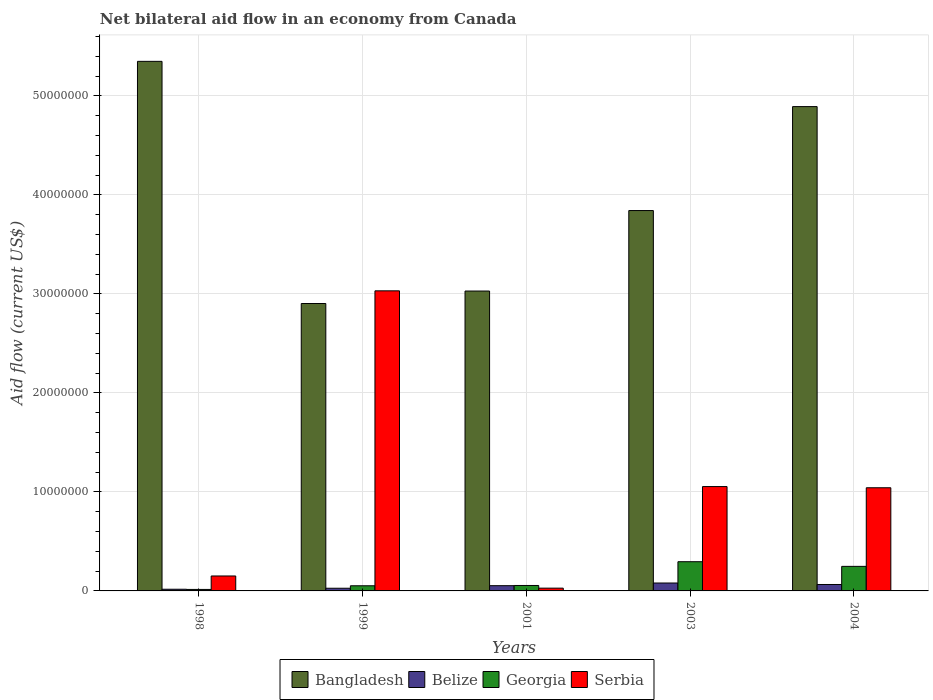How many groups of bars are there?
Ensure brevity in your answer.  5. Are the number of bars per tick equal to the number of legend labels?
Provide a succinct answer. Yes. Are the number of bars on each tick of the X-axis equal?
Offer a terse response. Yes. How many bars are there on the 3rd tick from the left?
Your response must be concise. 4. In how many cases, is the number of bars for a given year not equal to the number of legend labels?
Make the answer very short. 0. Across all years, what is the maximum net bilateral aid flow in Georgia?
Provide a succinct answer. 2.95e+06. Across all years, what is the minimum net bilateral aid flow in Georgia?
Your answer should be compact. 1.50e+05. What is the total net bilateral aid flow in Bangladesh in the graph?
Offer a very short reply. 2.00e+08. What is the difference between the net bilateral aid flow in Serbia in 2003 and that in 2004?
Offer a very short reply. 1.20e+05. What is the difference between the net bilateral aid flow in Bangladesh in 2003 and the net bilateral aid flow in Belize in 2004?
Ensure brevity in your answer.  3.78e+07. What is the average net bilateral aid flow in Bangladesh per year?
Your answer should be very brief. 4.00e+07. In the year 2001, what is the difference between the net bilateral aid flow in Georgia and net bilateral aid flow in Bangladesh?
Ensure brevity in your answer.  -2.97e+07. In how many years, is the net bilateral aid flow in Georgia greater than 40000000 US$?
Provide a short and direct response. 0. What is the ratio of the net bilateral aid flow in Georgia in 1998 to that in 2003?
Give a very brief answer. 0.05. What is the difference between the highest and the second highest net bilateral aid flow in Serbia?
Your answer should be very brief. 1.98e+07. What is the difference between the highest and the lowest net bilateral aid flow in Bangladesh?
Provide a succinct answer. 2.45e+07. Is the sum of the net bilateral aid flow in Georgia in 2001 and 2003 greater than the maximum net bilateral aid flow in Serbia across all years?
Keep it short and to the point. No. Is it the case that in every year, the sum of the net bilateral aid flow in Georgia and net bilateral aid flow in Belize is greater than the sum of net bilateral aid flow in Serbia and net bilateral aid flow in Bangladesh?
Make the answer very short. No. What does the 4th bar from the left in 1999 represents?
Your response must be concise. Serbia. What does the 2nd bar from the right in 1999 represents?
Your answer should be compact. Georgia. Is it the case that in every year, the sum of the net bilateral aid flow in Georgia and net bilateral aid flow in Bangladesh is greater than the net bilateral aid flow in Belize?
Offer a very short reply. Yes. Are all the bars in the graph horizontal?
Your answer should be very brief. No. How many years are there in the graph?
Provide a short and direct response. 5. What is the difference between two consecutive major ticks on the Y-axis?
Offer a terse response. 1.00e+07. Are the values on the major ticks of Y-axis written in scientific E-notation?
Provide a short and direct response. No. Does the graph contain grids?
Make the answer very short. Yes. Where does the legend appear in the graph?
Ensure brevity in your answer.  Bottom center. What is the title of the graph?
Provide a succinct answer. Net bilateral aid flow in an economy from Canada. Does "Equatorial Guinea" appear as one of the legend labels in the graph?
Offer a terse response. No. What is the label or title of the X-axis?
Make the answer very short. Years. What is the Aid flow (current US$) in Bangladesh in 1998?
Make the answer very short. 5.35e+07. What is the Aid flow (current US$) of Georgia in 1998?
Provide a succinct answer. 1.50e+05. What is the Aid flow (current US$) of Serbia in 1998?
Offer a very short reply. 1.51e+06. What is the Aid flow (current US$) in Bangladesh in 1999?
Your response must be concise. 2.90e+07. What is the Aid flow (current US$) in Belize in 1999?
Keep it short and to the point. 2.70e+05. What is the Aid flow (current US$) of Georgia in 1999?
Ensure brevity in your answer.  5.20e+05. What is the Aid flow (current US$) in Serbia in 1999?
Ensure brevity in your answer.  3.03e+07. What is the Aid flow (current US$) in Bangladesh in 2001?
Your answer should be compact. 3.03e+07. What is the Aid flow (current US$) in Belize in 2001?
Your answer should be very brief. 5.30e+05. What is the Aid flow (current US$) of Bangladesh in 2003?
Provide a succinct answer. 3.84e+07. What is the Aid flow (current US$) of Georgia in 2003?
Provide a short and direct response. 2.95e+06. What is the Aid flow (current US$) in Serbia in 2003?
Keep it short and to the point. 1.05e+07. What is the Aid flow (current US$) in Bangladesh in 2004?
Ensure brevity in your answer.  4.89e+07. What is the Aid flow (current US$) of Belize in 2004?
Your response must be concise. 6.50e+05. What is the Aid flow (current US$) of Georgia in 2004?
Your answer should be very brief. 2.48e+06. What is the Aid flow (current US$) in Serbia in 2004?
Offer a very short reply. 1.04e+07. Across all years, what is the maximum Aid flow (current US$) of Bangladesh?
Provide a short and direct response. 5.35e+07. Across all years, what is the maximum Aid flow (current US$) of Georgia?
Offer a very short reply. 2.95e+06. Across all years, what is the maximum Aid flow (current US$) in Serbia?
Keep it short and to the point. 3.03e+07. Across all years, what is the minimum Aid flow (current US$) of Bangladesh?
Make the answer very short. 2.90e+07. Across all years, what is the minimum Aid flow (current US$) in Georgia?
Keep it short and to the point. 1.50e+05. Across all years, what is the minimum Aid flow (current US$) of Serbia?
Your answer should be very brief. 2.80e+05. What is the total Aid flow (current US$) of Bangladesh in the graph?
Give a very brief answer. 2.00e+08. What is the total Aid flow (current US$) in Belize in the graph?
Keep it short and to the point. 2.42e+06. What is the total Aid flow (current US$) of Georgia in the graph?
Make the answer very short. 6.65e+06. What is the total Aid flow (current US$) of Serbia in the graph?
Ensure brevity in your answer.  5.31e+07. What is the difference between the Aid flow (current US$) in Bangladesh in 1998 and that in 1999?
Provide a succinct answer. 2.45e+07. What is the difference between the Aid flow (current US$) of Georgia in 1998 and that in 1999?
Give a very brief answer. -3.70e+05. What is the difference between the Aid flow (current US$) in Serbia in 1998 and that in 1999?
Offer a terse response. -2.88e+07. What is the difference between the Aid flow (current US$) in Bangladesh in 1998 and that in 2001?
Provide a short and direct response. 2.32e+07. What is the difference between the Aid flow (current US$) in Belize in 1998 and that in 2001?
Your answer should be very brief. -3.60e+05. What is the difference between the Aid flow (current US$) in Georgia in 1998 and that in 2001?
Give a very brief answer. -4.00e+05. What is the difference between the Aid flow (current US$) of Serbia in 1998 and that in 2001?
Keep it short and to the point. 1.23e+06. What is the difference between the Aid flow (current US$) of Bangladesh in 1998 and that in 2003?
Offer a terse response. 1.51e+07. What is the difference between the Aid flow (current US$) of Belize in 1998 and that in 2003?
Ensure brevity in your answer.  -6.30e+05. What is the difference between the Aid flow (current US$) of Georgia in 1998 and that in 2003?
Keep it short and to the point. -2.80e+06. What is the difference between the Aid flow (current US$) in Serbia in 1998 and that in 2003?
Your answer should be very brief. -9.03e+06. What is the difference between the Aid flow (current US$) in Bangladesh in 1998 and that in 2004?
Make the answer very short. 4.57e+06. What is the difference between the Aid flow (current US$) in Belize in 1998 and that in 2004?
Make the answer very short. -4.80e+05. What is the difference between the Aid flow (current US$) in Georgia in 1998 and that in 2004?
Offer a very short reply. -2.33e+06. What is the difference between the Aid flow (current US$) of Serbia in 1998 and that in 2004?
Make the answer very short. -8.91e+06. What is the difference between the Aid flow (current US$) of Bangladesh in 1999 and that in 2001?
Provide a succinct answer. -1.26e+06. What is the difference between the Aid flow (current US$) of Serbia in 1999 and that in 2001?
Offer a very short reply. 3.00e+07. What is the difference between the Aid flow (current US$) in Bangladesh in 1999 and that in 2003?
Ensure brevity in your answer.  -9.39e+06. What is the difference between the Aid flow (current US$) of Belize in 1999 and that in 2003?
Your answer should be very brief. -5.30e+05. What is the difference between the Aid flow (current US$) of Georgia in 1999 and that in 2003?
Give a very brief answer. -2.43e+06. What is the difference between the Aid flow (current US$) of Serbia in 1999 and that in 2003?
Give a very brief answer. 1.98e+07. What is the difference between the Aid flow (current US$) in Bangladesh in 1999 and that in 2004?
Your answer should be compact. -1.99e+07. What is the difference between the Aid flow (current US$) of Belize in 1999 and that in 2004?
Provide a short and direct response. -3.80e+05. What is the difference between the Aid flow (current US$) in Georgia in 1999 and that in 2004?
Offer a terse response. -1.96e+06. What is the difference between the Aid flow (current US$) in Serbia in 1999 and that in 2004?
Make the answer very short. 1.99e+07. What is the difference between the Aid flow (current US$) in Bangladesh in 2001 and that in 2003?
Provide a succinct answer. -8.13e+06. What is the difference between the Aid flow (current US$) in Belize in 2001 and that in 2003?
Give a very brief answer. -2.70e+05. What is the difference between the Aid flow (current US$) of Georgia in 2001 and that in 2003?
Give a very brief answer. -2.40e+06. What is the difference between the Aid flow (current US$) in Serbia in 2001 and that in 2003?
Your answer should be compact. -1.03e+07. What is the difference between the Aid flow (current US$) in Bangladesh in 2001 and that in 2004?
Make the answer very short. -1.86e+07. What is the difference between the Aid flow (current US$) in Georgia in 2001 and that in 2004?
Make the answer very short. -1.93e+06. What is the difference between the Aid flow (current US$) of Serbia in 2001 and that in 2004?
Your answer should be compact. -1.01e+07. What is the difference between the Aid flow (current US$) of Bangladesh in 2003 and that in 2004?
Provide a succinct answer. -1.05e+07. What is the difference between the Aid flow (current US$) of Serbia in 2003 and that in 2004?
Provide a short and direct response. 1.20e+05. What is the difference between the Aid flow (current US$) in Bangladesh in 1998 and the Aid flow (current US$) in Belize in 1999?
Offer a terse response. 5.32e+07. What is the difference between the Aid flow (current US$) in Bangladesh in 1998 and the Aid flow (current US$) in Georgia in 1999?
Ensure brevity in your answer.  5.30e+07. What is the difference between the Aid flow (current US$) of Bangladesh in 1998 and the Aid flow (current US$) of Serbia in 1999?
Give a very brief answer. 2.32e+07. What is the difference between the Aid flow (current US$) in Belize in 1998 and the Aid flow (current US$) in Georgia in 1999?
Your answer should be very brief. -3.50e+05. What is the difference between the Aid flow (current US$) in Belize in 1998 and the Aid flow (current US$) in Serbia in 1999?
Give a very brief answer. -3.01e+07. What is the difference between the Aid flow (current US$) of Georgia in 1998 and the Aid flow (current US$) of Serbia in 1999?
Provide a succinct answer. -3.02e+07. What is the difference between the Aid flow (current US$) of Bangladesh in 1998 and the Aid flow (current US$) of Belize in 2001?
Ensure brevity in your answer.  5.30e+07. What is the difference between the Aid flow (current US$) of Bangladesh in 1998 and the Aid flow (current US$) of Georgia in 2001?
Your response must be concise. 5.29e+07. What is the difference between the Aid flow (current US$) of Bangladesh in 1998 and the Aid flow (current US$) of Serbia in 2001?
Make the answer very short. 5.32e+07. What is the difference between the Aid flow (current US$) of Belize in 1998 and the Aid flow (current US$) of Georgia in 2001?
Your response must be concise. -3.80e+05. What is the difference between the Aid flow (current US$) of Belize in 1998 and the Aid flow (current US$) of Serbia in 2001?
Offer a very short reply. -1.10e+05. What is the difference between the Aid flow (current US$) in Georgia in 1998 and the Aid flow (current US$) in Serbia in 2001?
Your answer should be very brief. -1.30e+05. What is the difference between the Aid flow (current US$) in Bangladesh in 1998 and the Aid flow (current US$) in Belize in 2003?
Offer a terse response. 5.27e+07. What is the difference between the Aid flow (current US$) in Bangladesh in 1998 and the Aid flow (current US$) in Georgia in 2003?
Make the answer very short. 5.05e+07. What is the difference between the Aid flow (current US$) in Bangladesh in 1998 and the Aid flow (current US$) in Serbia in 2003?
Offer a terse response. 4.30e+07. What is the difference between the Aid flow (current US$) of Belize in 1998 and the Aid flow (current US$) of Georgia in 2003?
Offer a terse response. -2.78e+06. What is the difference between the Aid flow (current US$) in Belize in 1998 and the Aid flow (current US$) in Serbia in 2003?
Offer a very short reply. -1.04e+07. What is the difference between the Aid flow (current US$) in Georgia in 1998 and the Aid flow (current US$) in Serbia in 2003?
Keep it short and to the point. -1.04e+07. What is the difference between the Aid flow (current US$) in Bangladesh in 1998 and the Aid flow (current US$) in Belize in 2004?
Keep it short and to the point. 5.28e+07. What is the difference between the Aid flow (current US$) in Bangladesh in 1998 and the Aid flow (current US$) in Georgia in 2004?
Provide a succinct answer. 5.10e+07. What is the difference between the Aid flow (current US$) of Bangladesh in 1998 and the Aid flow (current US$) of Serbia in 2004?
Keep it short and to the point. 4.31e+07. What is the difference between the Aid flow (current US$) of Belize in 1998 and the Aid flow (current US$) of Georgia in 2004?
Give a very brief answer. -2.31e+06. What is the difference between the Aid flow (current US$) in Belize in 1998 and the Aid flow (current US$) in Serbia in 2004?
Your answer should be very brief. -1.02e+07. What is the difference between the Aid flow (current US$) of Georgia in 1998 and the Aid flow (current US$) of Serbia in 2004?
Provide a succinct answer. -1.03e+07. What is the difference between the Aid flow (current US$) of Bangladesh in 1999 and the Aid flow (current US$) of Belize in 2001?
Give a very brief answer. 2.85e+07. What is the difference between the Aid flow (current US$) of Bangladesh in 1999 and the Aid flow (current US$) of Georgia in 2001?
Offer a terse response. 2.85e+07. What is the difference between the Aid flow (current US$) in Bangladesh in 1999 and the Aid flow (current US$) in Serbia in 2001?
Offer a terse response. 2.88e+07. What is the difference between the Aid flow (current US$) of Belize in 1999 and the Aid flow (current US$) of Georgia in 2001?
Provide a short and direct response. -2.80e+05. What is the difference between the Aid flow (current US$) of Belize in 1999 and the Aid flow (current US$) of Serbia in 2001?
Your answer should be compact. -10000. What is the difference between the Aid flow (current US$) of Georgia in 1999 and the Aid flow (current US$) of Serbia in 2001?
Your response must be concise. 2.40e+05. What is the difference between the Aid flow (current US$) of Bangladesh in 1999 and the Aid flow (current US$) of Belize in 2003?
Make the answer very short. 2.82e+07. What is the difference between the Aid flow (current US$) in Bangladesh in 1999 and the Aid flow (current US$) in Georgia in 2003?
Keep it short and to the point. 2.61e+07. What is the difference between the Aid flow (current US$) in Bangladesh in 1999 and the Aid flow (current US$) in Serbia in 2003?
Provide a succinct answer. 1.85e+07. What is the difference between the Aid flow (current US$) of Belize in 1999 and the Aid flow (current US$) of Georgia in 2003?
Provide a succinct answer. -2.68e+06. What is the difference between the Aid flow (current US$) of Belize in 1999 and the Aid flow (current US$) of Serbia in 2003?
Keep it short and to the point. -1.03e+07. What is the difference between the Aid flow (current US$) in Georgia in 1999 and the Aid flow (current US$) in Serbia in 2003?
Provide a succinct answer. -1.00e+07. What is the difference between the Aid flow (current US$) of Bangladesh in 1999 and the Aid flow (current US$) of Belize in 2004?
Make the answer very short. 2.84e+07. What is the difference between the Aid flow (current US$) in Bangladesh in 1999 and the Aid flow (current US$) in Georgia in 2004?
Provide a succinct answer. 2.66e+07. What is the difference between the Aid flow (current US$) in Bangladesh in 1999 and the Aid flow (current US$) in Serbia in 2004?
Keep it short and to the point. 1.86e+07. What is the difference between the Aid flow (current US$) of Belize in 1999 and the Aid flow (current US$) of Georgia in 2004?
Keep it short and to the point. -2.21e+06. What is the difference between the Aid flow (current US$) of Belize in 1999 and the Aid flow (current US$) of Serbia in 2004?
Provide a short and direct response. -1.02e+07. What is the difference between the Aid flow (current US$) of Georgia in 1999 and the Aid flow (current US$) of Serbia in 2004?
Make the answer very short. -9.90e+06. What is the difference between the Aid flow (current US$) in Bangladesh in 2001 and the Aid flow (current US$) in Belize in 2003?
Provide a short and direct response. 2.95e+07. What is the difference between the Aid flow (current US$) of Bangladesh in 2001 and the Aid flow (current US$) of Georgia in 2003?
Your response must be concise. 2.73e+07. What is the difference between the Aid flow (current US$) in Bangladesh in 2001 and the Aid flow (current US$) in Serbia in 2003?
Make the answer very short. 1.98e+07. What is the difference between the Aid flow (current US$) in Belize in 2001 and the Aid flow (current US$) in Georgia in 2003?
Your answer should be very brief. -2.42e+06. What is the difference between the Aid flow (current US$) of Belize in 2001 and the Aid flow (current US$) of Serbia in 2003?
Provide a succinct answer. -1.00e+07. What is the difference between the Aid flow (current US$) in Georgia in 2001 and the Aid flow (current US$) in Serbia in 2003?
Offer a very short reply. -9.99e+06. What is the difference between the Aid flow (current US$) of Bangladesh in 2001 and the Aid flow (current US$) of Belize in 2004?
Ensure brevity in your answer.  2.96e+07. What is the difference between the Aid flow (current US$) of Bangladesh in 2001 and the Aid flow (current US$) of Georgia in 2004?
Make the answer very short. 2.78e+07. What is the difference between the Aid flow (current US$) in Bangladesh in 2001 and the Aid flow (current US$) in Serbia in 2004?
Provide a succinct answer. 1.99e+07. What is the difference between the Aid flow (current US$) in Belize in 2001 and the Aid flow (current US$) in Georgia in 2004?
Give a very brief answer. -1.95e+06. What is the difference between the Aid flow (current US$) of Belize in 2001 and the Aid flow (current US$) of Serbia in 2004?
Provide a short and direct response. -9.89e+06. What is the difference between the Aid flow (current US$) in Georgia in 2001 and the Aid flow (current US$) in Serbia in 2004?
Your answer should be compact. -9.87e+06. What is the difference between the Aid flow (current US$) of Bangladesh in 2003 and the Aid flow (current US$) of Belize in 2004?
Keep it short and to the point. 3.78e+07. What is the difference between the Aid flow (current US$) in Bangladesh in 2003 and the Aid flow (current US$) in Georgia in 2004?
Offer a terse response. 3.59e+07. What is the difference between the Aid flow (current US$) in Bangladesh in 2003 and the Aid flow (current US$) in Serbia in 2004?
Ensure brevity in your answer.  2.80e+07. What is the difference between the Aid flow (current US$) of Belize in 2003 and the Aid flow (current US$) of Georgia in 2004?
Make the answer very short. -1.68e+06. What is the difference between the Aid flow (current US$) in Belize in 2003 and the Aid flow (current US$) in Serbia in 2004?
Offer a very short reply. -9.62e+06. What is the difference between the Aid flow (current US$) in Georgia in 2003 and the Aid flow (current US$) in Serbia in 2004?
Offer a very short reply. -7.47e+06. What is the average Aid flow (current US$) of Bangladesh per year?
Provide a short and direct response. 4.00e+07. What is the average Aid flow (current US$) of Belize per year?
Your response must be concise. 4.84e+05. What is the average Aid flow (current US$) of Georgia per year?
Ensure brevity in your answer.  1.33e+06. What is the average Aid flow (current US$) in Serbia per year?
Give a very brief answer. 1.06e+07. In the year 1998, what is the difference between the Aid flow (current US$) of Bangladesh and Aid flow (current US$) of Belize?
Your response must be concise. 5.33e+07. In the year 1998, what is the difference between the Aid flow (current US$) in Bangladesh and Aid flow (current US$) in Georgia?
Give a very brief answer. 5.33e+07. In the year 1998, what is the difference between the Aid flow (current US$) of Bangladesh and Aid flow (current US$) of Serbia?
Make the answer very short. 5.20e+07. In the year 1998, what is the difference between the Aid flow (current US$) in Belize and Aid flow (current US$) in Georgia?
Your answer should be very brief. 2.00e+04. In the year 1998, what is the difference between the Aid flow (current US$) of Belize and Aid flow (current US$) of Serbia?
Keep it short and to the point. -1.34e+06. In the year 1998, what is the difference between the Aid flow (current US$) of Georgia and Aid flow (current US$) of Serbia?
Offer a terse response. -1.36e+06. In the year 1999, what is the difference between the Aid flow (current US$) in Bangladesh and Aid flow (current US$) in Belize?
Offer a terse response. 2.88e+07. In the year 1999, what is the difference between the Aid flow (current US$) in Bangladesh and Aid flow (current US$) in Georgia?
Your answer should be compact. 2.85e+07. In the year 1999, what is the difference between the Aid flow (current US$) of Bangladesh and Aid flow (current US$) of Serbia?
Keep it short and to the point. -1.28e+06. In the year 1999, what is the difference between the Aid flow (current US$) of Belize and Aid flow (current US$) of Georgia?
Offer a very short reply. -2.50e+05. In the year 1999, what is the difference between the Aid flow (current US$) in Belize and Aid flow (current US$) in Serbia?
Offer a terse response. -3.00e+07. In the year 1999, what is the difference between the Aid flow (current US$) of Georgia and Aid flow (current US$) of Serbia?
Your answer should be compact. -2.98e+07. In the year 2001, what is the difference between the Aid flow (current US$) in Bangladesh and Aid flow (current US$) in Belize?
Your answer should be very brief. 2.98e+07. In the year 2001, what is the difference between the Aid flow (current US$) of Bangladesh and Aid flow (current US$) of Georgia?
Make the answer very short. 2.97e+07. In the year 2001, what is the difference between the Aid flow (current US$) of Bangladesh and Aid flow (current US$) of Serbia?
Give a very brief answer. 3.00e+07. In the year 2001, what is the difference between the Aid flow (current US$) in Belize and Aid flow (current US$) in Georgia?
Your answer should be compact. -2.00e+04. In the year 2001, what is the difference between the Aid flow (current US$) in Belize and Aid flow (current US$) in Serbia?
Provide a succinct answer. 2.50e+05. In the year 2003, what is the difference between the Aid flow (current US$) of Bangladesh and Aid flow (current US$) of Belize?
Offer a very short reply. 3.76e+07. In the year 2003, what is the difference between the Aid flow (current US$) of Bangladesh and Aid flow (current US$) of Georgia?
Your answer should be very brief. 3.55e+07. In the year 2003, what is the difference between the Aid flow (current US$) in Bangladesh and Aid flow (current US$) in Serbia?
Make the answer very short. 2.79e+07. In the year 2003, what is the difference between the Aid flow (current US$) in Belize and Aid flow (current US$) in Georgia?
Your response must be concise. -2.15e+06. In the year 2003, what is the difference between the Aid flow (current US$) of Belize and Aid flow (current US$) of Serbia?
Your answer should be very brief. -9.74e+06. In the year 2003, what is the difference between the Aid flow (current US$) in Georgia and Aid flow (current US$) in Serbia?
Your answer should be compact. -7.59e+06. In the year 2004, what is the difference between the Aid flow (current US$) in Bangladesh and Aid flow (current US$) in Belize?
Your response must be concise. 4.83e+07. In the year 2004, what is the difference between the Aid flow (current US$) of Bangladesh and Aid flow (current US$) of Georgia?
Ensure brevity in your answer.  4.64e+07. In the year 2004, what is the difference between the Aid flow (current US$) in Bangladesh and Aid flow (current US$) in Serbia?
Provide a short and direct response. 3.85e+07. In the year 2004, what is the difference between the Aid flow (current US$) of Belize and Aid flow (current US$) of Georgia?
Keep it short and to the point. -1.83e+06. In the year 2004, what is the difference between the Aid flow (current US$) in Belize and Aid flow (current US$) in Serbia?
Keep it short and to the point. -9.77e+06. In the year 2004, what is the difference between the Aid flow (current US$) in Georgia and Aid flow (current US$) in Serbia?
Offer a very short reply. -7.94e+06. What is the ratio of the Aid flow (current US$) in Bangladesh in 1998 to that in 1999?
Make the answer very short. 1.84. What is the ratio of the Aid flow (current US$) in Belize in 1998 to that in 1999?
Your answer should be compact. 0.63. What is the ratio of the Aid flow (current US$) in Georgia in 1998 to that in 1999?
Ensure brevity in your answer.  0.29. What is the ratio of the Aid flow (current US$) in Serbia in 1998 to that in 1999?
Ensure brevity in your answer.  0.05. What is the ratio of the Aid flow (current US$) in Bangladesh in 1998 to that in 2001?
Your answer should be very brief. 1.77. What is the ratio of the Aid flow (current US$) of Belize in 1998 to that in 2001?
Your response must be concise. 0.32. What is the ratio of the Aid flow (current US$) in Georgia in 1998 to that in 2001?
Offer a very short reply. 0.27. What is the ratio of the Aid flow (current US$) of Serbia in 1998 to that in 2001?
Offer a terse response. 5.39. What is the ratio of the Aid flow (current US$) in Bangladesh in 1998 to that in 2003?
Provide a short and direct response. 1.39. What is the ratio of the Aid flow (current US$) in Belize in 1998 to that in 2003?
Offer a terse response. 0.21. What is the ratio of the Aid flow (current US$) of Georgia in 1998 to that in 2003?
Your answer should be compact. 0.05. What is the ratio of the Aid flow (current US$) of Serbia in 1998 to that in 2003?
Make the answer very short. 0.14. What is the ratio of the Aid flow (current US$) in Bangladesh in 1998 to that in 2004?
Make the answer very short. 1.09. What is the ratio of the Aid flow (current US$) of Belize in 1998 to that in 2004?
Provide a succinct answer. 0.26. What is the ratio of the Aid flow (current US$) in Georgia in 1998 to that in 2004?
Provide a short and direct response. 0.06. What is the ratio of the Aid flow (current US$) of Serbia in 1998 to that in 2004?
Your answer should be very brief. 0.14. What is the ratio of the Aid flow (current US$) of Bangladesh in 1999 to that in 2001?
Your answer should be compact. 0.96. What is the ratio of the Aid flow (current US$) of Belize in 1999 to that in 2001?
Offer a terse response. 0.51. What is the ratio of the Aid flow (current US$) of Georgia in 1999 to that in 2001?
Provide a succinct answer. 0.95. What is the ratio of the Aid flow (current US$) of Serbia in 1999 to that in 2001?
Provide a short and direct response. 108.25. What is the ratio of the Aid flow (current US$) in Bangladesh in 1999 to that in 2003?
Your answer should be compact. 0.76. What is the ratio of the Aid flow (current US$) of Belize in 1999 to that in 2003?
Keep it short and to the point. 0.34. What is the ratio of the Aid flow (current US$) of Georgia in 1999 to that in 2003?
Offer a very short reply. 0.18. What is the ratio of the Aid flow (current US$) of Serbia in 1999 to that in 2003?
Offer a very short reply. 2.88. What is the ratio of the Aid flow (current US$) in Bangladesh in 1999 to that in 2004?
Make the answer very short. 0.59. What is the ratio of the Aid flow (current US$) of Belize in 1999 to that in 2004?
Your response must be concise. 0.42. What is the ratio of the Aid flow (current US$) of Georgia in 1999 to that in 2004?
Provide a succinct answer. 0.21. What is the ratio of the Aid flow (current US$) in Serbia in 1999 to that in 2004?
Offer a very short reply. 2.91. What is the ratio of the Aid flow (current US$) of Bangladesh in 2001 to that in 2003?
Make the answer very short. 0.79. What is the ratio of the Aid flow (current US$) in Belize in 2001 to that in 2003?
Keep it short and to the point. 0.66. What is the ratio of the Aid flow (current US$) in Georgia in 2001 to that in 2003?
Make the answer very short. 0.19. What is the ratio of the Aid flow (current US$) of Serbia in 2001 to that in 2003?
Offer a very short reply. 0.03. What is the ratio of the Aid flow (current US$) in Bangladesh in 2001 to that in 2004?
Your response must be concise. 0.62. What is the ratio of the Aid flow (current US$) in Belize in 2001 to that in 2004?
Offer a terse response. 0.82. What is the ratio of the Aid flow (current US$) in Georgia in 2001 to that in 2004?
Make the answer very short. 0.22. What is the ratio of the Aid flow (current US$) in Serbia in 2001 to that in 2004?
Provide a short and direct response. 0.03. What is the ratio of the Aid flow (current US$) of Bangladesh in 2003 to that in 2004?
Keep it short and to the point. 0.79. What is the ratio of the Aid flow (current US$) in Belize in 2003 to that in 2004?
Ensure brevity in your answer.  1.23. What is the ratio of the Aid flow (current US$) of Georgia in 2003 to that in 2004?
Keep it short and to the point. 1.19. What is the ratio of the Aid flow (current US$) of Serbia in 2003 to that in 2004?
Your answer should be very brief. 1.01. What is the difference between the highest and the second highest Aid flow (current US$) in Bangladesh?
Give a very brief answer. 4.57e+06. What is the difference between the highest and the second highest Aid flow (current US$) of Serbia?
Offer a very short reply. 1.98e+07. What is the difference between the highest and the lowest Aid flow (current US$) of Bangladesh?
Offer a very short reply. 2.45e+07. What is the difference between the highest and the lowest Aid flow (current US$) in Belize?
Your answer should be very brief. 6.30e+05. What is the difference between the highest and the lowest Aid flow (current US$) in Georgia?
Provide a succinct answer. 2.80e+06. What is the difference between the highest and the lowest Aid flow (current US$) of Serbia?
Keep it short and to the point. 3.00e+07. 